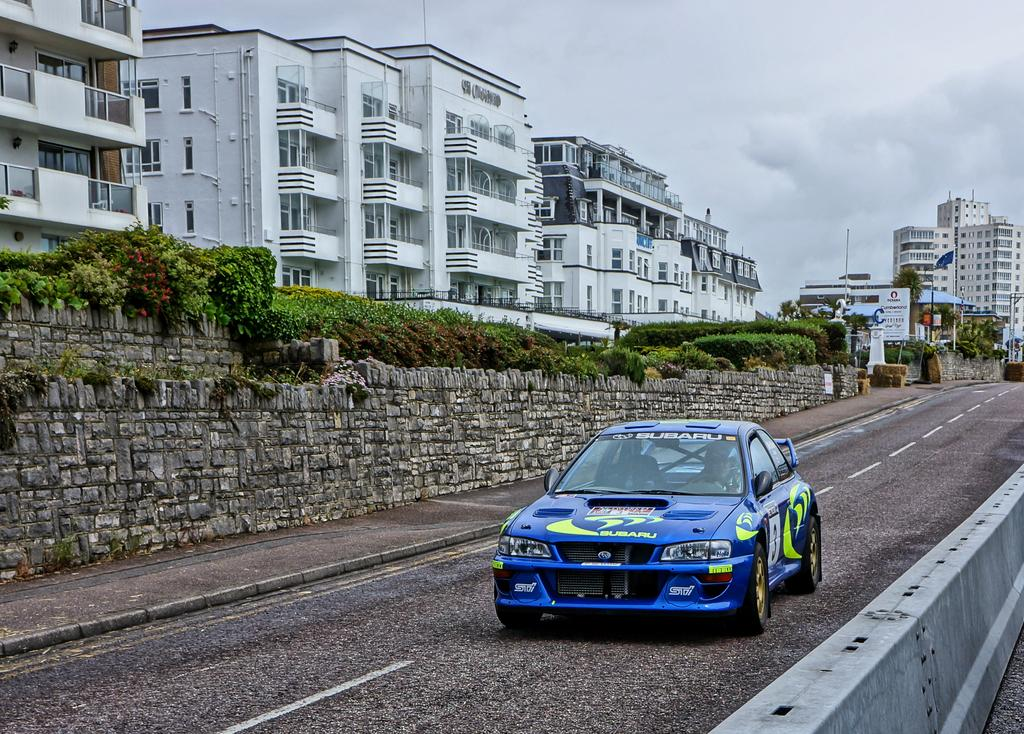What type of natural elements can be seen in the image? There are rocks, plants, and trees in the image. What type of man-made structures are present in the image? There are buildings in the image. What additional object can be seen in the image? There is a banner in the image. What type of vehicle is visible in the image? There is a blue color car in the image. What is visible in the sky in the image? The sky is visible in the image, along with clouds. What type of record is being played on the banner in the image? There is no record or music player present in the image; the banner is just a flat object. What type of skirt is being worn by the trees in the image? There are no skirts or clothing items present in the image; the trees are just natural vegetation. 